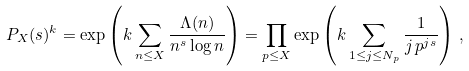Convert formula to latex. <formula><loc_0><loc_0><loc_500><loc_500>P _ { X } ( s ) ^ { k } = \exp \left ( k \sum _ { n \leq X } \frac { \Lambda ( n ) } { n ^ { s } \log n } \right ) = \prod _ { p \leq X } \exp \left ( k \sum _ { 1 \leq j \leq N _ { p } } \frac { 1 } { j \, p ^ { j s } } \right ) \, ,</formula> 